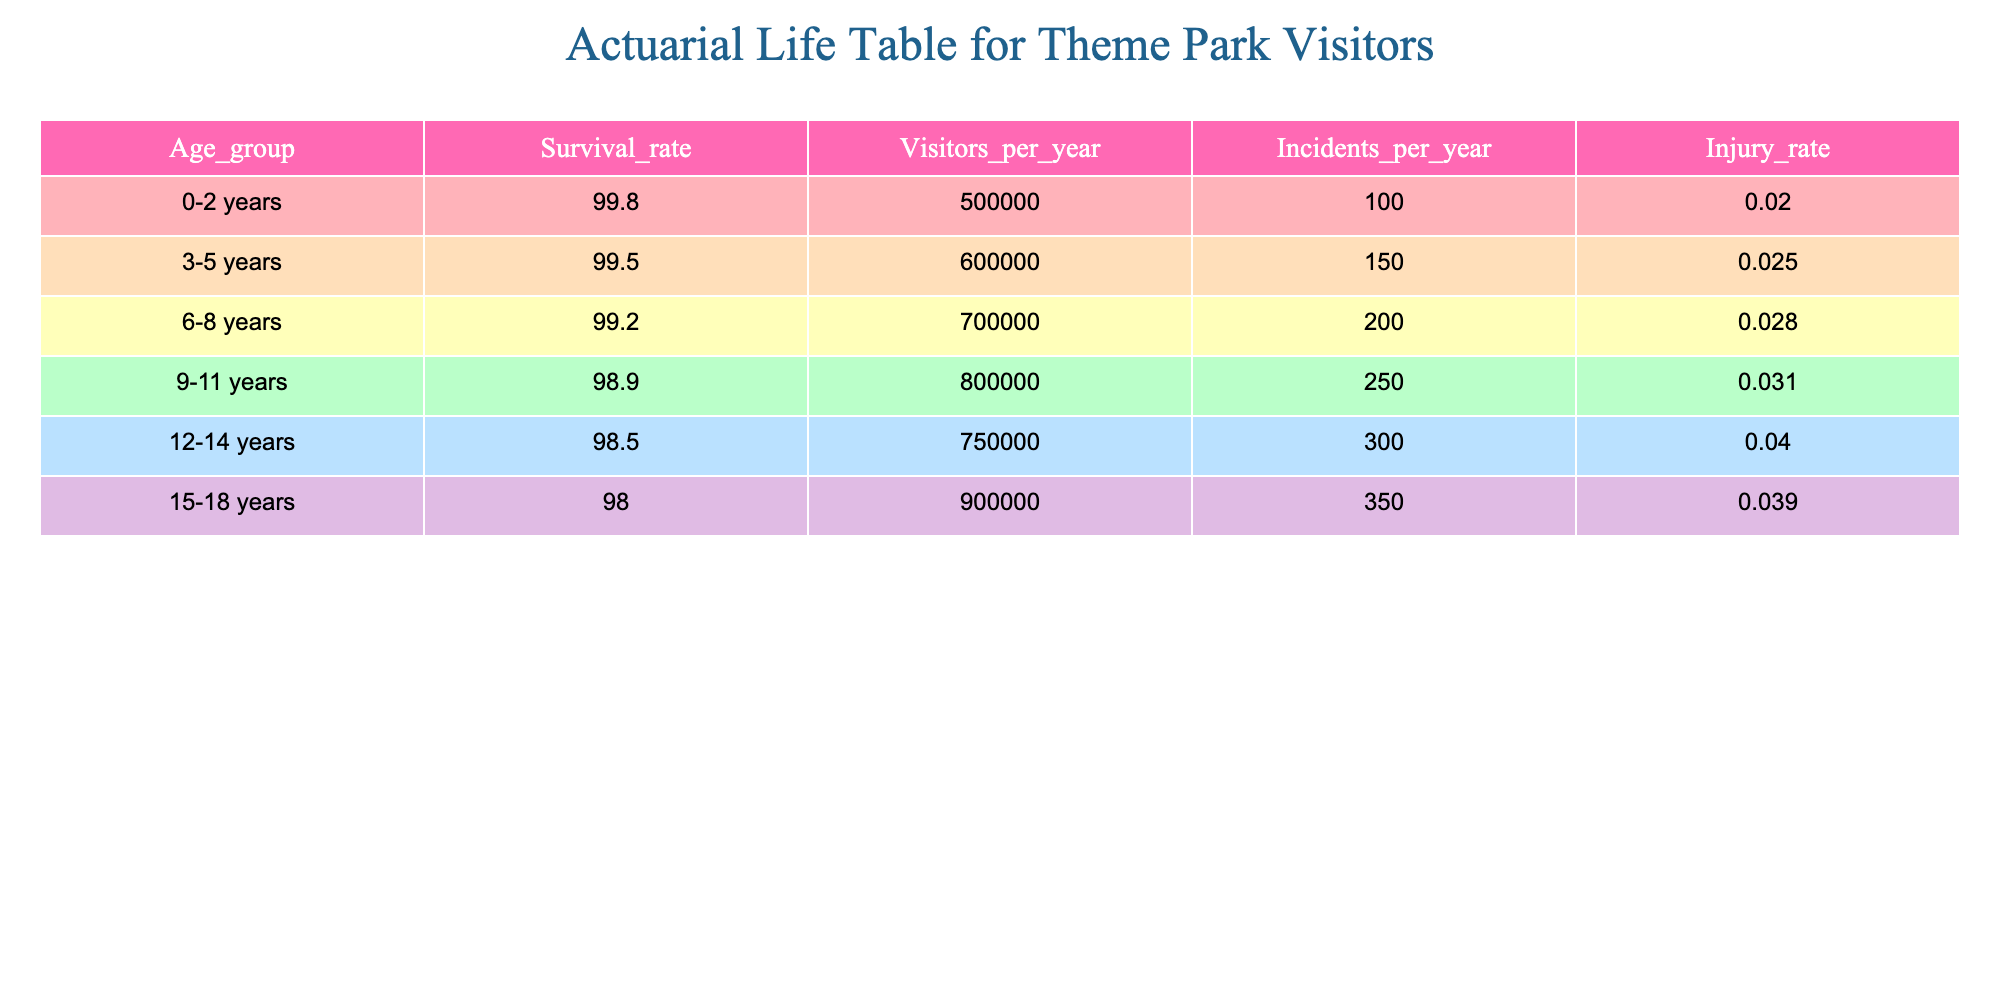What is the survival rate for children aged 3-5 years? The survival rate for the age group 3-5 years is listed directly in the table under the "Survival_rate" column for that specific age group. According to the table, it is 99.5.
Answer: 99.5 How many visitors are there for the age group 0-2 years? The number of visitors per year for the age group 0-2 years can be found in the table, specifically in the "Visitors_per_year" column. It states that there are 500,000 visitors for that age group.
Answer: 500,000 What is the injury rate for children aged 12-14 years? The injury rate for the age group 12-14 years is directly provided in the table in the "Injury_rate" column. It shows an injury rate of 0.04 for that specific age group.
Answer: 0.04 Which age group has the highest number of incidents per year? To find the age group with the highest number of incidents per year, we compare the values in the "Incidents_per_year" column for each age group. The age group 12-14 years has 300 incidents per year, which is the highest compared to other groups.
Answer: 12-14 years What is the average survival rate across all age groups listed? To find the average survival rate, sum all the survival rates from each age group and then divide by the number of age groups. The total is 99.8 + 99.5 + 99.2 + 98.9 + 98.5 + 98.0 = 594.9. Dividing by 6 yields an average of 99.15.
Answer: 99.15 Are there more visitors per year in the age group 9-11 years than in the age group 6-8 years? By comparing the "Visitors_per_year" values for the age groups, 800,000 (9-11 years) is greater than 700,000 (6-8 years), confirming that there are indeed more visitors in the 9-11 age group.
Answer: Yes What is the difference in injury rates between the 0-2 and 9-11 year age groups? The difference can be calculated by subtracting the injury rate of the 0-2 age group (0.02) from that of the 9-11 age group (0.031). This results in 0.031 - 0.02 = 0.011.
Answer: 0.011 If the trend continues, how many incidents can be expected for children aged 15-18 years based on the visitor data? The incident rate can be estimated by using the "Incidents_per_year" value for the age group 15-18 years, which is 350. This indicates that this age group has an expected number of 350 incidents per year based on the current data.
Answer: 350 Is the survival rate for children aged 6-8 years less than that of children aged 3-5 years? Comparing the survival rates, the survival rate for children aged 6-8 years is 99.2, while for those aged 3-5 years it is 99.5. Since 99.2 is less than 99.5, this statement is true.
Answer: Yes 